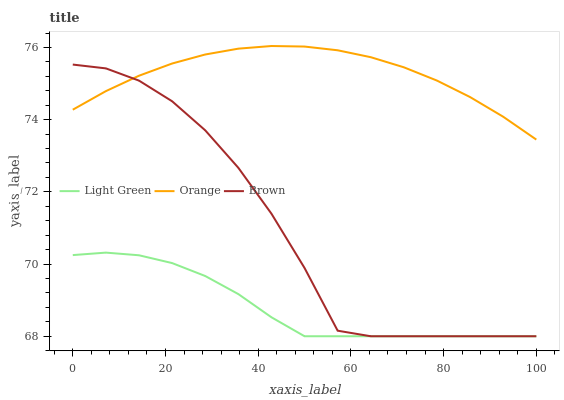Does Light Green have the minimum area under the curve?
Answer yes or no. Yes. Does Orange have the maximum area under the curve?
Answer yes or no. Yes. Does Brown have the minimum area under the curve?
Answer yes or no. No. Does Brown have the maximum area under the curve?
Answer yes or no. No. Is Orange the smoothest?
Answer yes or no. Yes. Is Brown the roughest?
Answer yes or no. Yes. Is Light Green the smoothest?
Answer yes or no. No. Is Light Green the roughest?
Answer yes or no. No. Does Brown have the lowest value?
Answer yes or no. Yes. Does Orange have the highest value?
Answer yes or no. Yes. Does Brown have the highest value?
Answer yes or no. No. Is Light Green less than Orange?
Answer yes or no. Yes. Is Orange greater than Light Green?
Answer yes or no. Yes. Does Light Green intersect Brown?
Answer yes or no. Yes. Is Light Green less than Brown?
Answer yes or no. No. Is Light Green greater than Brown?
Answer yes or no. No. Does Light Green intersect Orange?
Answer yes or no. No. 